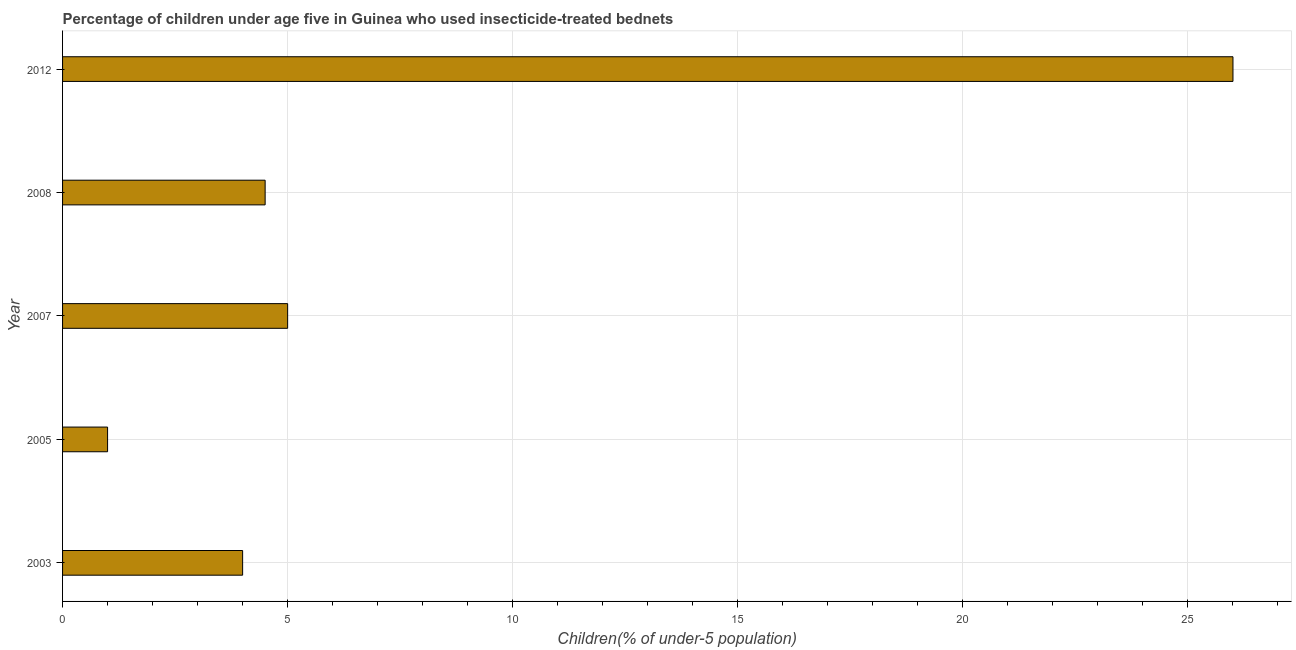What is the title of the graph?
Ensure brevity in your answer.  Percentage of children under age five in Guinea who used insecticide-treated bednets. What is the label or title of the X-axis?
Your response must be concise. Children(% of under-5 population). What is the percentage of children who use of insecticide-treated bed nets in 2008?
Offer a terse response. 4.5. Across all years, what is the maximum percentage of children who use of insecticide-treated bed nets?
Give a very brief answer. 26. Across all years, what is the minimum percentage of children who use of insecticide-treated bed nets?
Your answer should be compact. 1. In which year was the percentage of children who use of insecticide-treated bed nets minimum?
Keep it short and to the point. 2005. What is the sum of the percentage of children who use of insecticide-treated bed nets?
Your answer should be very brief. 40.5. What is the average percentage of children who use of insecticide-treated bed nets per year?
Your response must be concise. 8.1. What is the median percentage of children who use of insecticide-treated bed nets?
Provide a short and direct response. 4.5. In how many years, is the percentage of children who use of insecticide-treated bed nets greater than 12 %?
Provide a short and direct response. 1. Do a majority of the years between 2003 and 2008 (inclusive) have percentage of children who use of insecticide-treated bed nets greater than 20 %?
Your answer should be compact. No. What is the ratio of the percentage of children who use of insecticide-treated bed nets in 2003 to that in 2008?
Keep it short and to the point. 0.89. Is the difference between the percentage of children who use of insecticide-treated bed nets in 2003 and 2007 greater than the difference between any two years?
Offer a very short reply. No. Is the sum of the percentage of children who use of insecticide-treated bed nets in 2005 and 2008 greater than the maximum percentage of children who use of insecticide-treated bed nets across all years?
Provide a succinct answer. No. In how many years, is the percentage of children who use of insecticide-treated bed nets greater than the average percentage of children who use of insecticide-treated bed nets taken over all years?
Offer a very short reply. 1. Are all the bars in the graph horizontal?
Provide a succinct answer. Yes. What is the difference between two consecutive major ticks on the X-axis?
Keep it short and to the point. 5. Are the values on the major ticks of X-axis written in scientific E-notation?
Give a very brief answer. No. What is the Children(% of under-5 population) of 2003?
Your response must be concise. 4. What is the Children(% of under-5 population) in 2005?
Ensure brevity in your answer.  1. What is the Children(% of under-5 population) of 2008?
Provide a short and direct response. 4.5. What is the difference between the Children(% of under-5 population) in 2003 and 2007?
Offer a very short reply. -1. What is the difference between the Children(% of under-5 population) in 2003 and 2012?
Provide a short and direct response. -22. What is the difference between the Children(% of under-5 population) in 2005 and 2007?
Offer a very short reply. -4. What is the difference between the Children(% of under-5 population) in 2005 and 2008?
Provide a succinct answer. -3.5. What is the difference between the Children(% of under-5 population) in 2007 and 2012?
Make the answer very short. -21. What is the difference between the Children(% of under-5 population) in 2008 and 2012?
Give a very brief answer. -21.5. What is the ratio of the Children(% of under-5 population) in 2003 to that in 2008?
Ensure brevity in your answer.  0.89. What is the ratio of the Children(% of under-5 population) in 2003 to that in 2012?
Your response must be concise. 0.15. What is the ratio of the Children(% of under-5 population) in 2005 to that in 2008?
Your answer should be compact. 0.22. What is the ratio of the Children(% of under-5 population) in 2005 to that in 2012?
Your response must be concise. 0.04. What is the ratio of the Children(% of under-5 population) in 2007 to that in 2008?
Provide a short and direct response. 1.11. What is the ratio of the Children(% of under-5 population) in 2007 to that in 2012?
Your answer should be very brief. 0.19. What is the ratio of the Children(% of under-5 population) in 2008 to that in 2012?
Make the answer very short. 0.17. 